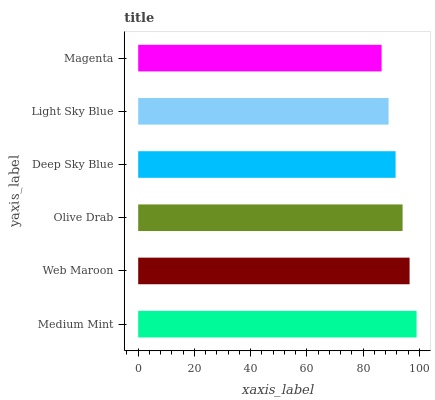Is Magenta the minimum?
Answer yes or no. Yes. Is Medium Mint the maximum?
Answer yes or no. Yes. Is Web Maroon the minimum?
Answer yes or no. No. Is Web Maroon the maximum?
Answer yes or no. No. Is Medium Mint greater than Web Maroon?
Answer yes or no. Yes. Is Web Maroon less than Medium Mint?
Answer yes or no. Yes. Is Web Maroon greater than Medium Mint?
Answer yes or no. No. Is Medium Mint less than Web Maroon?
Answer yes or no. No. Is Olive Drab the high median?
Answer yes or no. Yes. Is Deep Sky Blue the low median?
Answer yes or no. Yes. Is Light Sky Blue the high median?
Answer yes or no. No. Is Olive Drab the low median?
Answer yes or no. No. 